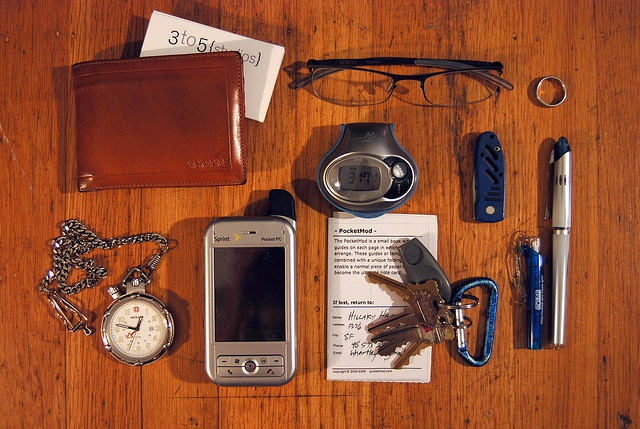Describe the objects in this image and their specific colors. I can see cell phone in maroon, black, and gray tones, clock in maroon, black, and gray tones, clock in maroon, tan, lightgray, and gray tones, and knife in maroon, navy, black, and gray tones in this image. 